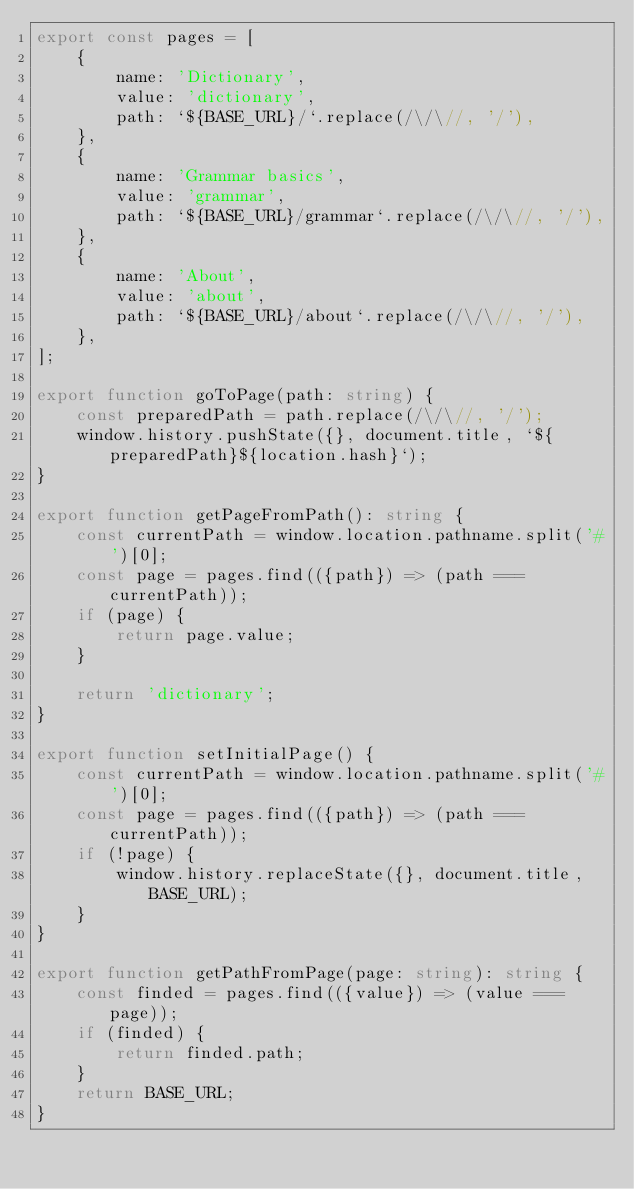Convert code to text. <code><loc_0><loc_0><loc_500><loc_500><_TypeScript_>export const pages = [
    {
        name: 'Dictionary',
        value: 'dictionary',
        path: `${BASE_URL}/`.replace(/\/\//, '/'),
    },
    {
        name: 'Grammar basics',
        value: 'grammar',
        path: `${BASE_URL}/grammar`.replace(/\/\//, '/'),
    },
    {
        name: 'About',
        value: 'about',
        path: `${BASE_URL}/about`.replace(/\/\//, '/'),
    },
];

export function goToPage(path: string) {
    const preparedPath = path.replace(/\/\//, '/');
    window.history.pushState({}, document.title, `${preparedPath}${location.hash}`);
}

export function getPageFromPath(): string {
    const currentPath = window.location.pathname.split('#')[0];
    const page = pages.find(({path}) => (path === currentPath));
    if (page) {
        return page.value;
    }

    return 'dictionary';
}

export function setInitialPage() {
    const currentPath = window.location.pathname.split('#')[0];
    const page = pages.find(({path}) => (path === currentPath));
    if (!page) {
        window.history.replaceState({}, document.title, BASE_URL);
    }
}

export function getPathFromPage(page: string): string {
    const finded = pages.find(({value}) => (value === page));
    if (finded) {
        return finded.path;
    }
    return BASE_URL;
}
</code> 